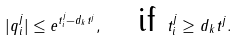Convert formula to latex. <formula><loc_0><loc_0><loc_500><loc_500>| q _ { i } ^ { j } | \leq e ^ { t _ { i } ^ { j } - d _ { k } t ^ { j } } , \quad \text {if } t _ { i } ^ { j } \geq d _ { k } t ^ { j } .</formula> 